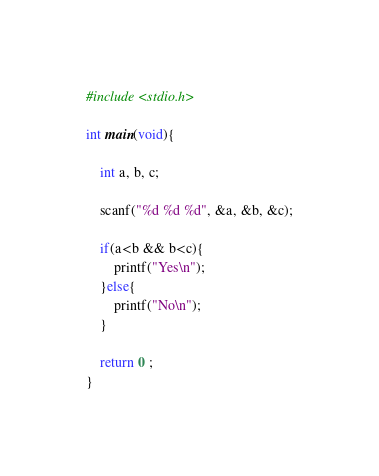Convert code to text. <code><loc_0><loc_0><loc_500><loc_500><_C_>#include <stdio.h>

int main(void){

    int a, b, c;

    scanf("%d %d %d", &a, &b, &c);

    if(a<b && b<c){
        printf("Yes\n");
    }else{
        printf("No\n");
    }

    return 0 ;
}</code> 